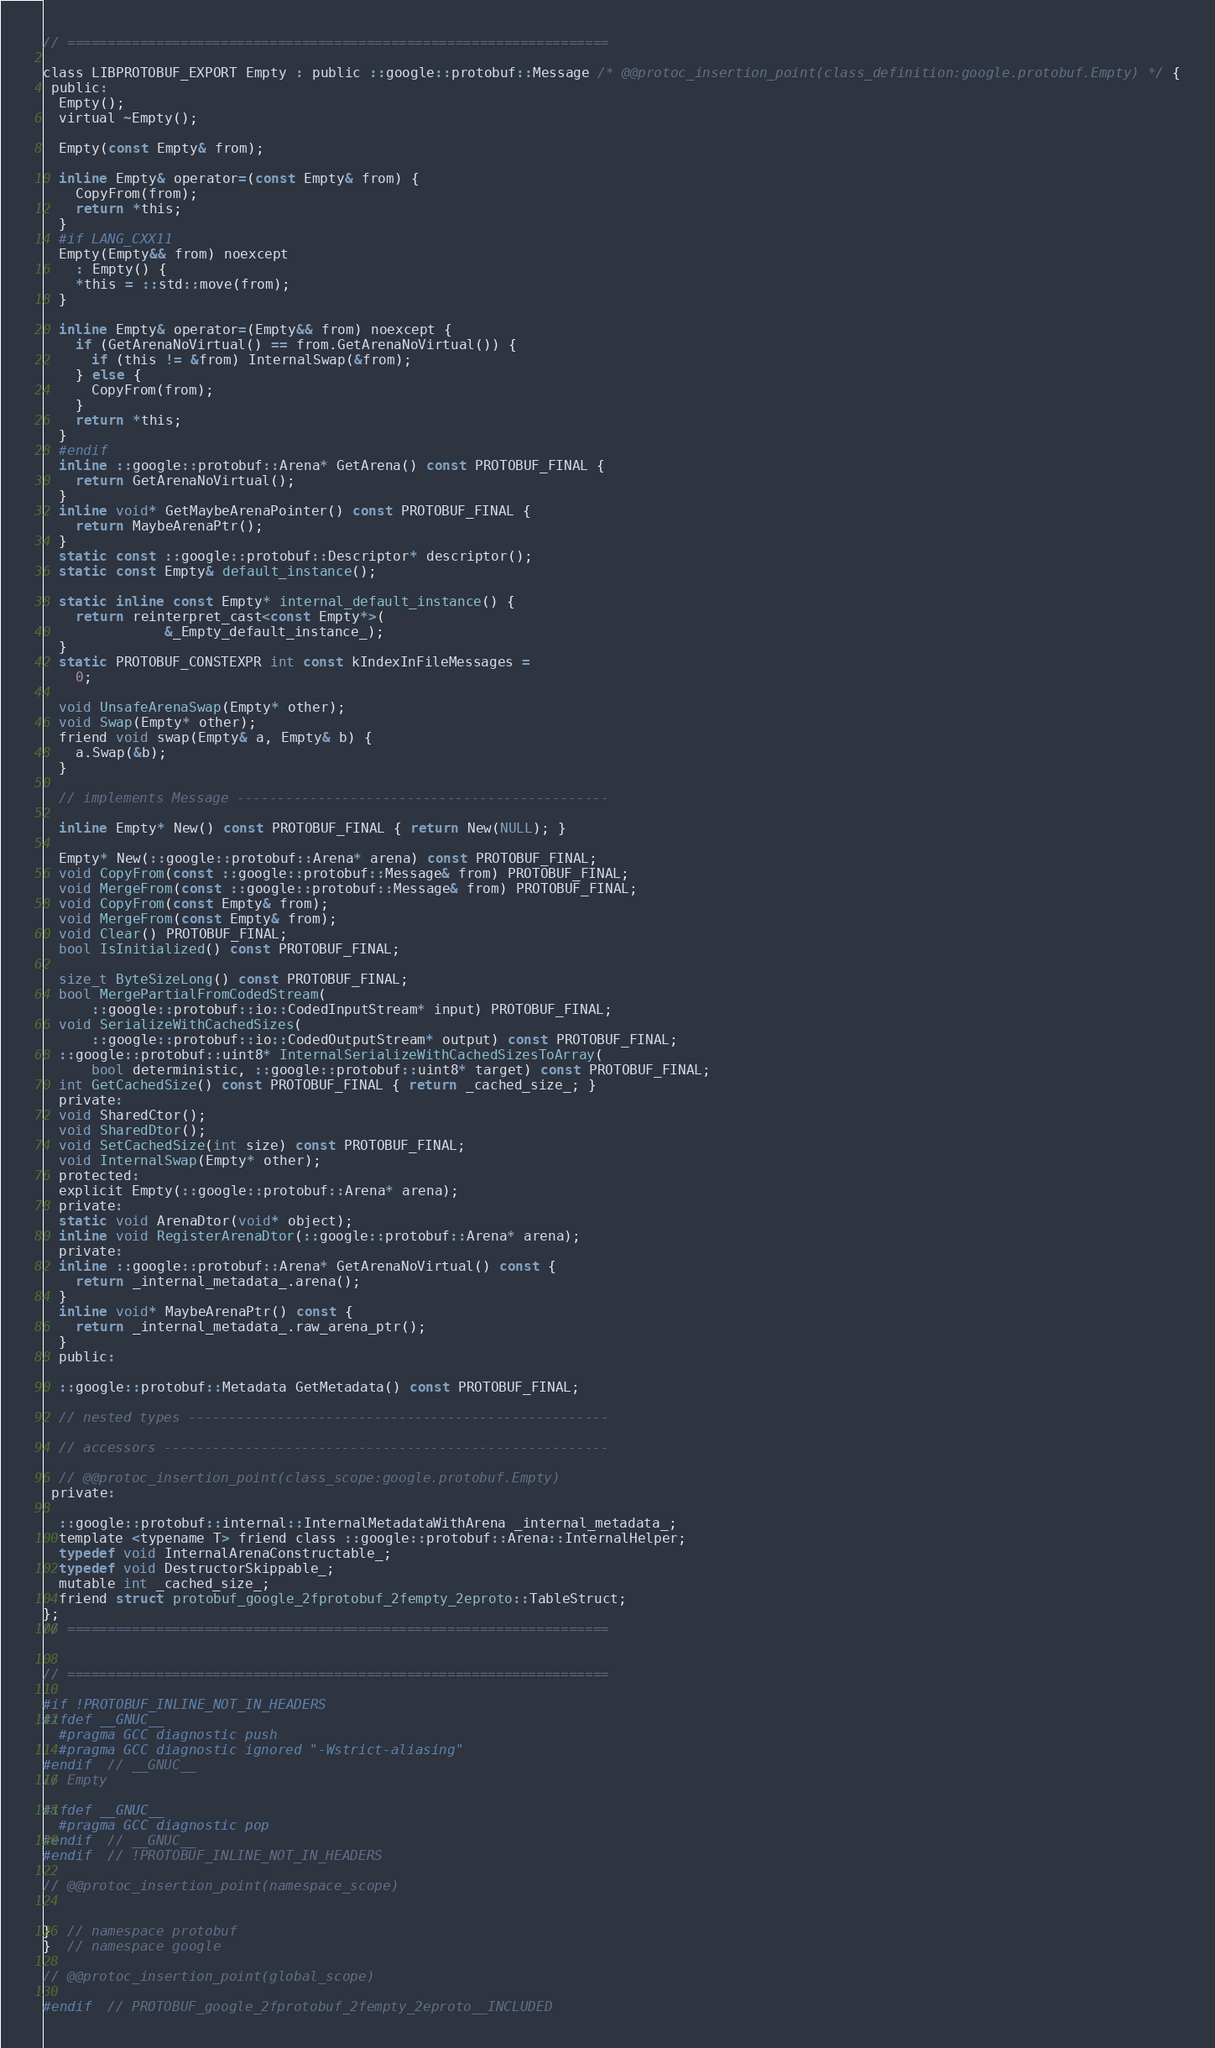Convert code to text. <code><loc_0><loc_0><loc_500><loc_500><_C_>// ===================================================================

class LIBPROTOBUF_EXPORT Empty : public ::google::protobuf::Message /* @@protoc_insertion_point(class_definition:google.protobuf.Empty) */ {
 public:
  Empty();
  virtual ~Empty();

  Empty(const Empty& from);

  inline Empty& operator=(const Empty& from) {
    CopyFrom(from);
    return *this;
  }
  #if LANG_CXX11
  Empty(Empty&& from) noexcept
    : Empty() {
    *this = ::std::move(from);
  }

  inline Empty& operator=(Empty&& from) noexcept {
    if (GetArenaNoVirtual() == from.GetArenaNoVirtual()) {
      if (this != &from) InternalSwap(&from);
    } else {
      CopyFrom(from);
    }
    return *this;
  }
  #endif
  inline ::google::protobuf::Arena* GetArena() const PROTOBUF_FINAL {
    return GetArenaNoVirtual();
  }
  inline void* GetMaybeArenaPointer() const PROTOBUF_FINAL {
    return MaybeArenaPtr();
  }
  static const ::google::protobuf::Descriptor* descriptor();
  static const Empty& default_instance();

  static inline const Empty* internal_default_instance() {
    return reinterpret_cast<const Empty*>(
               &_Empty_default_instance_);
  }
  static PROTOBUF_CONSTEXPR int const kIndexInFileMessages =
    0;

  void UnsafeArenaSwap(Empty* other);
  void Swap(Empty* other);
  friend void swap(Empty& a, Empty& b) {
    a.Swap(&b);
  }

  // implements Message ----------------------------------------------

  inline Empty* New() const PROTOBUF_FINAL { return New(NULL); }

  Empty* New(::google::protobuf::Arena* arena) const PROTOBUF_FINAL;
  void CopyFrom(const ::google::protobuf::Message& from) PROTOBUF_FINAL;
  void MergeFrom(const ::google::protobuf::Message& from) PROTOBUF_FINAL;
  void CopyFrom(const Empty& from);
  void MergeFrom(const Empty& from);
  void Clear() PROTOBUF_FINAL;
  bool IsInitialized() const PROTOBUF_FINAL;

  size_t ByteSizeLong() const PROTOBUF_FINAL;
  bool MergePartialFromCodedStream(
      ::google::protobuf::io::CodedInputStream* input) PROTOBUF_FINAL;
  void SerializeWithCachedSizes(
      ::google::protobuf::io::CodedOutputStream* output) const PROTOBUF_FINAL;
  ::google::protobuf::uint8* InternalSerializeWithCachedSizesToArray(
      bool deterministic, ::google::protobuf::uint8* target) const PROTOBUF_FINAL;
  int GetCachedSize() const PROTOBUF_FINAL { return _cached_size_; }
  private:
  void SharedCtor();
  void SharedDtor();
  void SetCachedSize(int size) const PROTOBUF_FINAL;
  void InternalSwap(Empty* other);
  protected:
  explicit Empty(::google::protobuf::Arena* arena);
  private:
  static void ArenaDtor(void* object);
  inline void RegisterArenaDtor(::google::protobuf::Arena* arena);
  private:
  inline ::google::protobuf::Arena* GetArenaNoVirtual() const {
    return _internal_metadata_.arena();
  }
  inline void* MaybeArenaPtr() const {
    return _internal_metadata_.raw_arena_ptr();
  }
  public:

  ::google::protobuf::Metadata GetMetadata() const PROTOBUF_FINAL;

  // nested types ----------------------------------------------------

  // accessors -------------------------------------------------------

  // @@protoc_insertion_point(class_scope:google.protobuf.Empty)
 private:

  ::google::protobuf::internal::InternalMetadataWithArena _internal_metadata_;
  template <typename T> friend class ::google::protobuf::Arena::InternalHelper;
  typedef void InternalArenaConstructable_;
  typedef void DestructorSkippable_;
  mutable int _cached_size_;
  friend struct protobuf_google_2fprotobuf_2fempty_2eproto::TableStruct;
};
// ===================================================================


// ===================================================================

#if !PROTOBUF_INLINE_NOT_IN_HEADERS
#ifdef __GNUC__
  #pragma GCC diagnostic push
  #pragma GCC diagnostic ignored "-Wstrict-aliasing"
#endif  // __GNUC__
// Empty

#ifdef __GNUC__
  #pragma GCC diagnostic pop
#endif  // __GNUC__
#endif  // !PROTOBUF_INLINE_NOT_IN_HEADERS

// @@protoc_insertion_point(namespace_scope)


}  // namespace protobuf
}  // namespace google

// @@protoc_insertion_point(global_scope)

#endif  // PROTOBUF_google_2fprotobuf_2fempty_2eproto__INCLUDED
</code> 